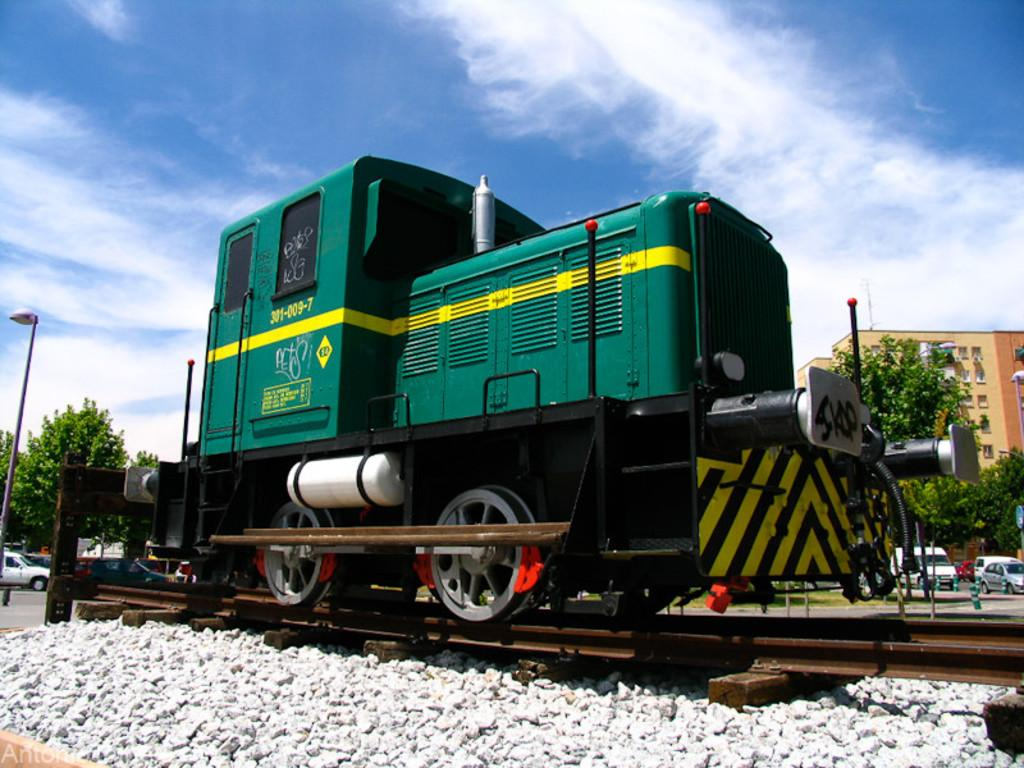What is the color of the train in the image? The train in the image is green. Where is the train located? The train is on a railway track. What can be seen in the background of the image? There are trees, vehicles, a building, and glass windows visible in the background. What is the color of the sky in the image? The sky is blue and white in color. Can you see an apple hanging from the tree in the image? There is no apple visible in the image; only trees are present in the background. 